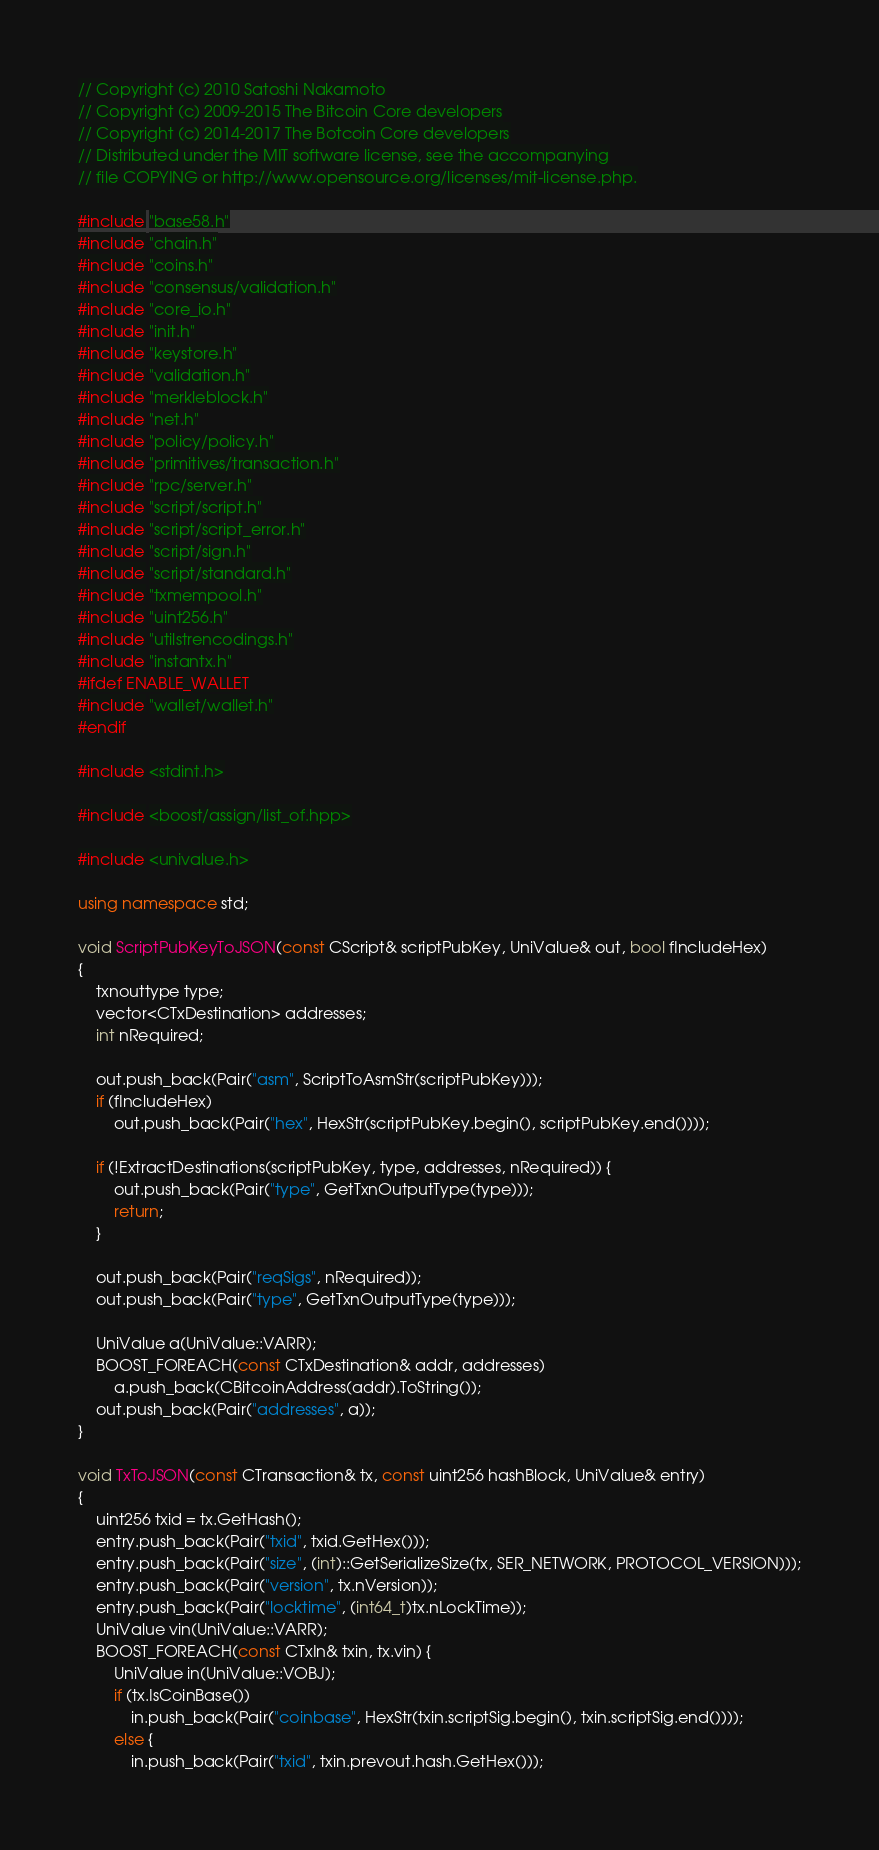Convert code to text. <code><loc_0><loc_0><loc_500><loc_500><_C++_>// Copyright (c) 2010 Satoshi Nakamoto
// Copyright (c) 2009-2015 The Bitcoin Core developers
// Copyright (c) 2014-2017 The Botcoin Core developers
// Distributed under the MIT software license, see the accompanying
// file COPYING or http://www.opensource.org/licenses/mit-license.php.

#include "base58.h"
#include "chain.h"
#include "coins.h"
#include "consensus/validation.h"
#include "core_io.h"
#include "init.h"
#include "keystore.h"
#include "validation.h"
#include "merkleblock.h"
#include "net.h"
#include "policy/policy.h"
#include "primitives/transaction.h"
#include "rpc/server.h"
#include "script/script.h"
#include "script/script_error.h"
#include "script/sign.h"
#include "script/standard.h"
#include "txmempool.h"
#include "uint256.h"
#include "utilstrencodings.h"
#include "instantx.h"
#ifdef ENABLE_WALLET
#include "wallet/wallet.h"
#endif

#include <stdint.h>

#include <boost/assign/list_of.hpp>

#include <univalue.h>

using namespace std;

void ScriptPubKeyToJSON(const CScript& scriptPubKey, UniValue& out, bool fIncludeHex)
{
    txnouttype type;
    vector<CTxDestination> addresses;
    int nRequired;

    out.push_back(Pair("asm", ScriptToAsmStr(scriptPubKey)));
    if (fIncludeHex)
        out.push_back(Pair("hex", HexStr(scriptPubKey.begin(), scriptPubKey.end())));

    if (!ExtractDestinations(scriptPubKey, type, addresses, nRequired)) {
        out.push_back(Pair("type", GetTxnOutputType(type)));
        return;
    }

    out.push_back(Pair("reqSigs", nRequired));
    out.push_back(Pair("type", GetTxnOutputType(type)));

    UniValue a(UniValue::VARR);
    BOOST_FOREACH(const CTxDestination& addr, addresses)
        a.push_back(CBitcoinAddress(addr).ToString());
    out.push_back(Pair("addresses", a));
}

void TxToJSON(const CTransaction& tx, const uint256 hashBlock, UniValue& entry)
{
    uint256 txid = tx.GetHash();
    entry.push_back(Pair("txid", txid.GetHex()));
    entry.push_back(Pair("size", (int)::GetSerializeSize(tx, SER_NETWORK, PROTOCOL_VERSION)));
    entry.push_back(Pair("version", tx.nVersion));
    entry.push_back(Pair("locktime", (int64_t)tx.nLockTime));
    UniValue vin(UniValue::VARR);
    BOOST_FOREACH(const CTxIn& txin, tx.vin) {
        UniValue in(UniValue::VOBJ);
        if (tx.IsCoinBase())
            in.push_back(Pair("coinbase", HexStr(txin.scriptSig.begin(), txin.scriptSig.end())));
        else {
            in.push_back(Pair("txid", txin.prevout.hash.GetHex()));</code> 